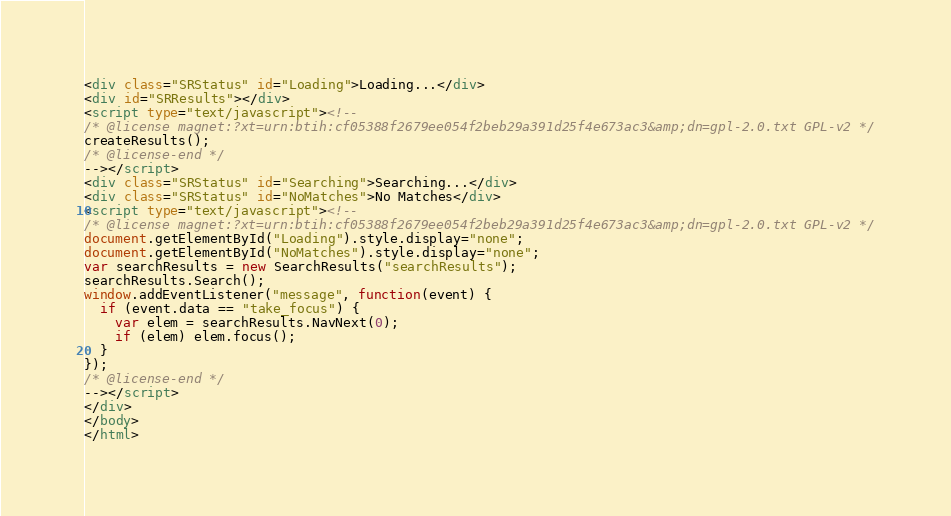Convert code to text. <code><loc_0><loc_0><loc_500><loc_500><_HTML_><div class="SRStatus" id="Loading">Loading...</div>
<div id="SRResults"></div>
<script type="text/javascript"><!--
/* @license magnet:?xt=urn:btih:cf05388f2679ee054f2beb29a391d25f4e673ac3&amp;dn=gpl-2.0.txt GPL-v2 */
createResults();
/* @license-end */
--></script>
<div class="SRStatus" id="Searching">Searching...</div>
<div class="SRStatus" id="NoMatches">No Matches</div>
<script type="text/javascript"><!--
/* @license magnet:?xt=urn:btih:cf05388f2679ee054f2beb29a391d25f4e673ac3&amp;dn=gpl-2.0.txt GPL-v2 */
document.getElementById("Loading").style.display="none";
document.getElementById("NoMatches").style.display="none";
var searchResults = new SearchResults("searchResults");
searchResults.Search();
window.addEventListener("message", function(event) {
  if (event.data == "take_focus") {
    var elem = searchResults.NavNext(0);
    if (elem) elem.focus();
  }
});
/* @license-end */
--></script>
</div>
</body>
</html>
</code> 